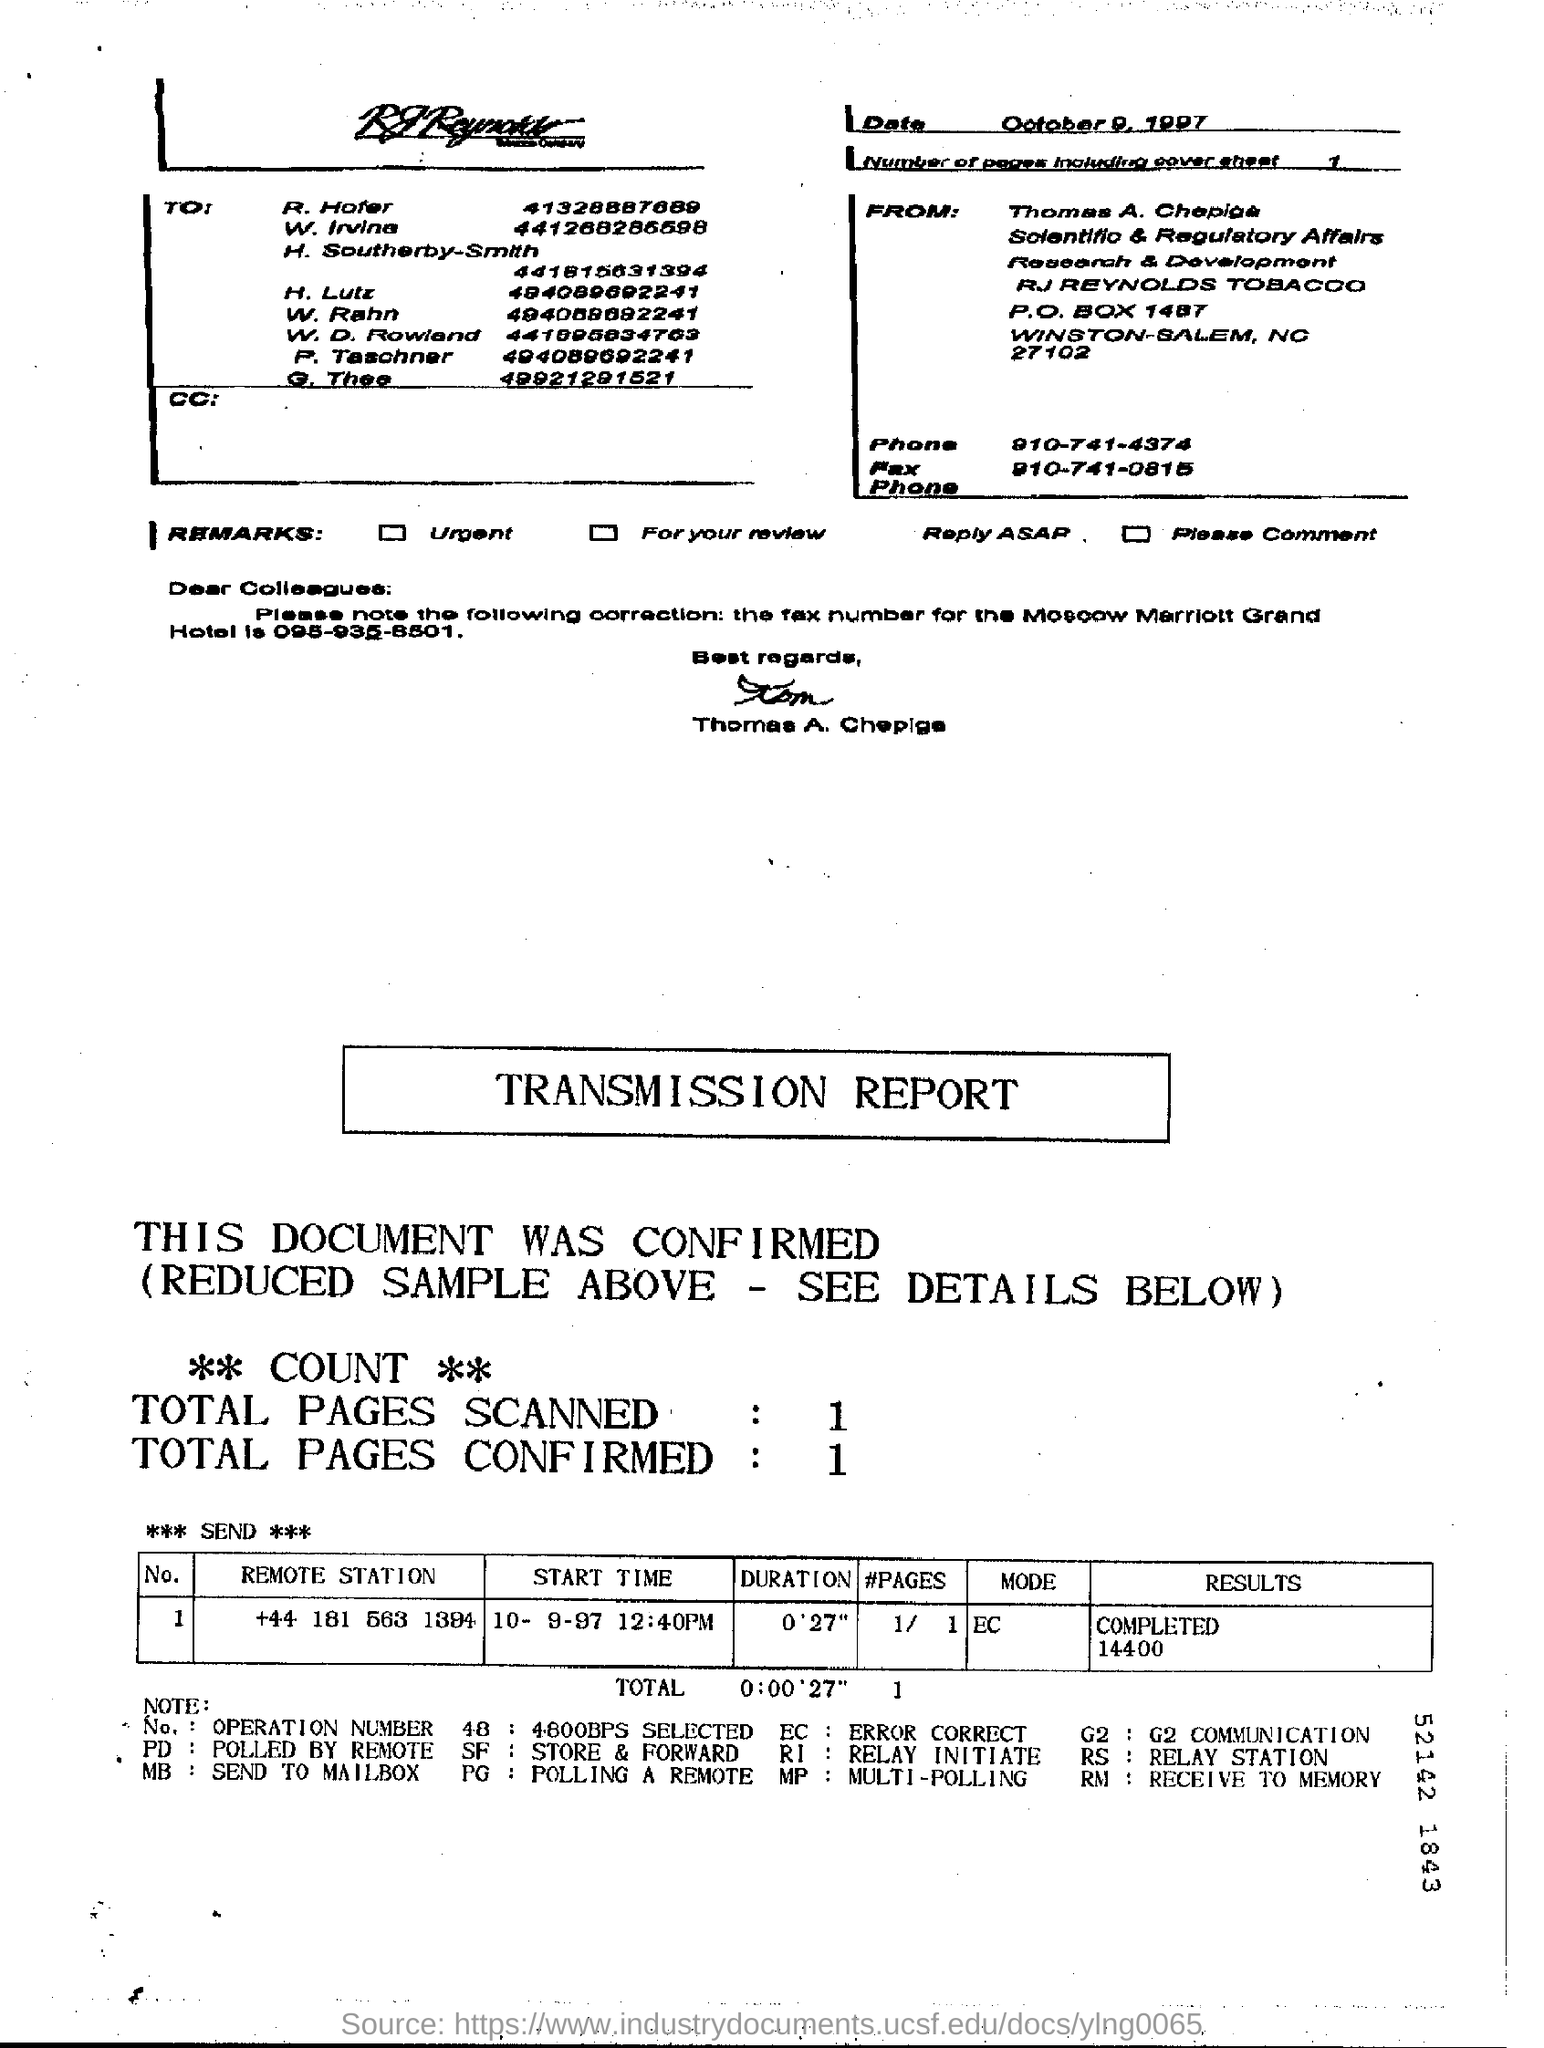What is the date which the message was sent?
Your answer should be very brief. October 9, 1997. 